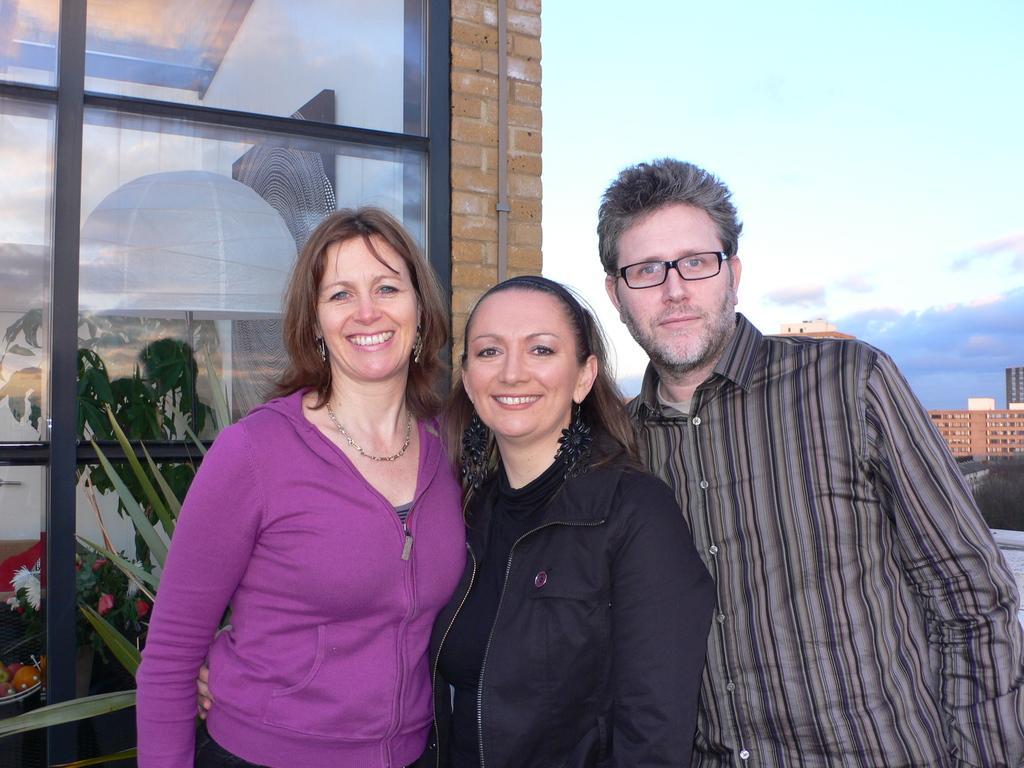Can you describe this image briefly? In this image I can see three persons standing. There is a transparent glass door or a wall and there are reflections on it. There are buildings, plants and in the background there is sky. 